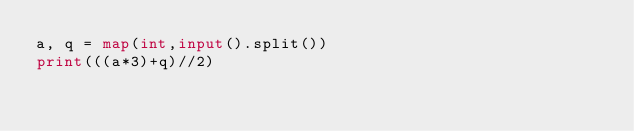Convert code to text. <code><loc_0><loc_0><loc_500><loc_500><_Python_>a, q = map(int,input().split())
print(((a*3)+q)//2)</code> 